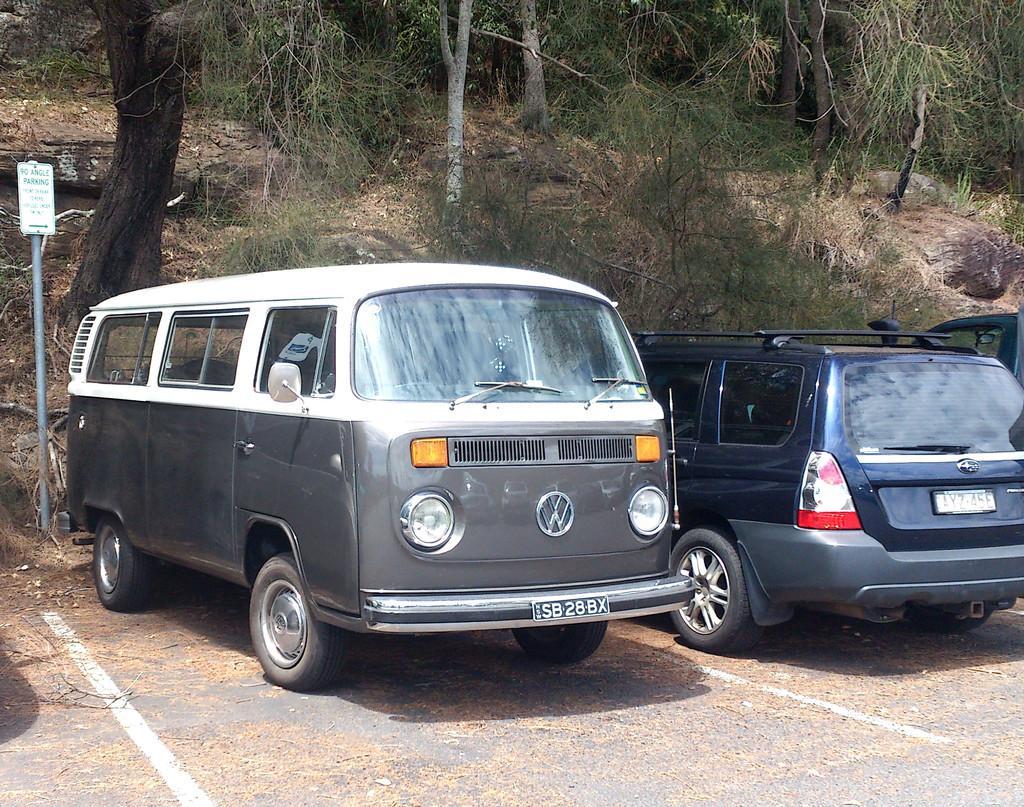Could you give a brief overview of what you see in this image? In the image there is a van and two cars on the side of the road with trees and plants behind it on the hill with a board on the right side. 